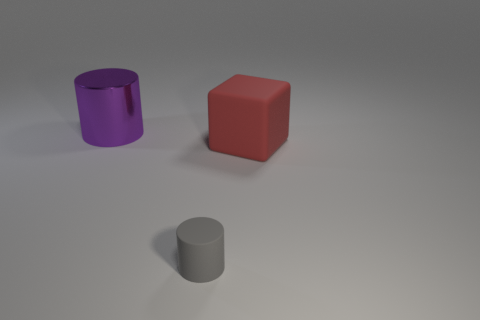Add 2 gray objects. How many objects exist? 5 Subtract all blocks. How many objects are left? 2 Subtract all metallic cylinders. Subtract all red objects. How many objects are left? 1 Add 3 purple metallic objects. How many purple metallic objects are left? 4 Add 2 blue cubes. How many blue cubes exist? 2 Subtract 0 red spheres. How many objects are left? 3 